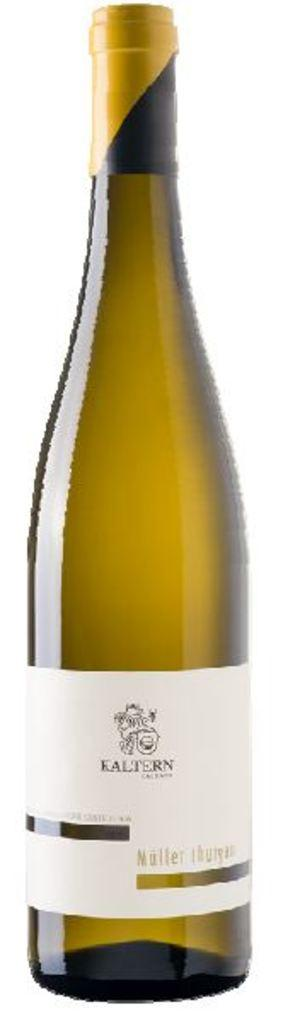What object can be seen in the picture? There is a bottle in the picture. What color is the cap on the bottle? The cap on the bottle is yellow. What else is present on the bottle besides the cap? There is a label on the bottle. What information can be found on the label? The label contains text and has a logo. What type of order is being discussed at the party in the image? There is no party or order present in the image; it only features a bottle with a yellow cap and a labeled container. 